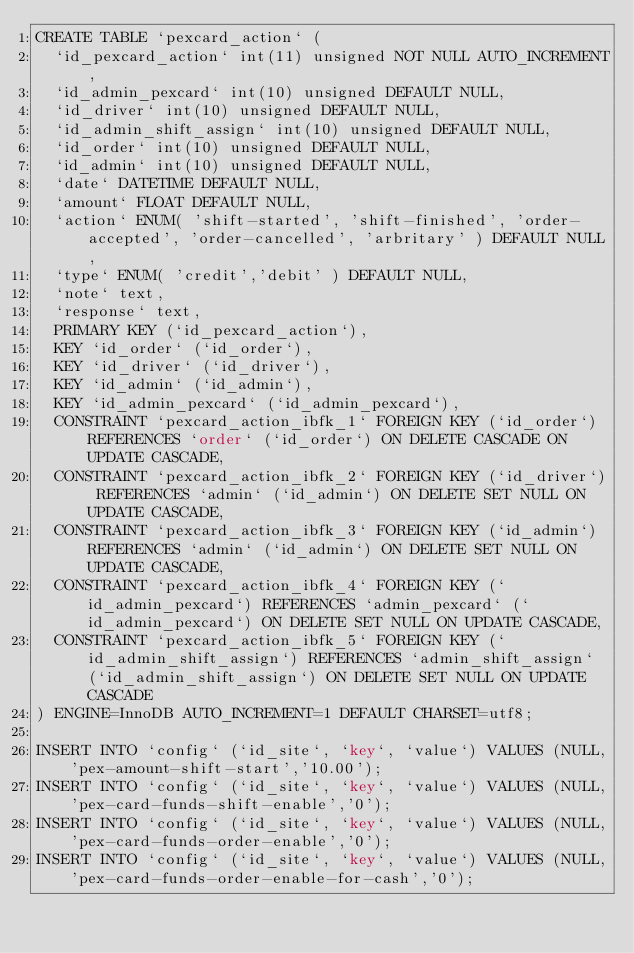Convert code to text. <code><loc_0><loc_0><loc_500><loc_500><_SQL_>CREATE TABLE `pexcard_action` (
  `id_pexcard_action` int(11) unsigned NOT NULL AUTO_INCREMENT,
  `id_admin_pexcard` int(10) unsigned DEFAULT NULL,
  `id_driver` int(10) unsigned DEFAULT NULL,
  `id_admin_shift_assign` int(10) unsigned DEFAULT NULL,
  `id_order` int(10) unsigned DEFAULT NULL,
  `id_admin` int(10) unsigned DEFAULT NULL,
  `date` DATETIME DEFAULT NULL,
  `amount` FLOAT DEFAULT NULL,
  `action` ENUM( 'shift-started', 'shift-finished', 'order-accepted', 'order-cancelled', 'arbritary' ) DEFAULT NULL,
  `type` ENUM( 'credit','debit' ) DEFAULT NULL,
  `note` text,
  `response` text,
  PRIMARY KEY (`id_pexcard_action`),
  KEY `id_order` (`id_order`),
  KEY `id_driver` (`id_driver`),
  KEY `id_admin` (`id_admin`),
  KEY `id_admin_pexcard` (`id_admin_pexcard`),
  CONSTRAINT `pexcard_action_ibfk_1` FOREIGN KEY (`id_order`) REFERENCES `order` (`id_order`) ON DELETE CASCADE ON UPDATE CASCADE,
  CONSTRAINT `pexcard_action_ibfk_2` FOREIGN KEY (`id_driver`) REFERENCES `admin` (`id_admin`) ON DELETE SET NULL ON UPDATE CASCADE,
  CONSTRAINT `pexcard_action_ibfk_3` FOREIGN KEY (`id_admin`) REFERENCES `admin` (`id_admin`) ON DELETE SET NULL ON UPDATE CASCADE,
  CONSTRAINT `pexcard_action_ibfk_4` FOREIGN KEY (`id_admin_pexcard`) REFERENCES `admin_pexcard` (`id_admin_pexcard`) ON DELETE SET NULL ON UPDATE CASCADE,
  CONSTRAINT `pexcard_action_ibfk_5` FOREIGN KEY (`id_admin_shift_assign`) REFERENCES `admin_shift_assign` (`id_admin_shift_assign`) ON DELETE SET NULL ON UPDATE CASCADE
) ENGINE=InnoDB AUTO_INCREMENT=1 DEFAULT CHARSET=utf8;

INSERT INTO `config` (`id_site`, `key`, `value`) VALUES (NULL,'pex-amount-shift-start','10.00');
INSERT INTO `config` (`id_site`, `key`, `value`) VALUES (NULL,'pex-card-funds-shift-enable','0');
INSERT INTO `config` (`id_site`, `key`, `value`) VALUES (NULL,'pex-card-funds-order-enable','0');
INSERT INTO `config` (`id_site`, `key`, `value`) VALUES (NULL,'pex-card-funds-order-enable-for-cash','0');</code> 